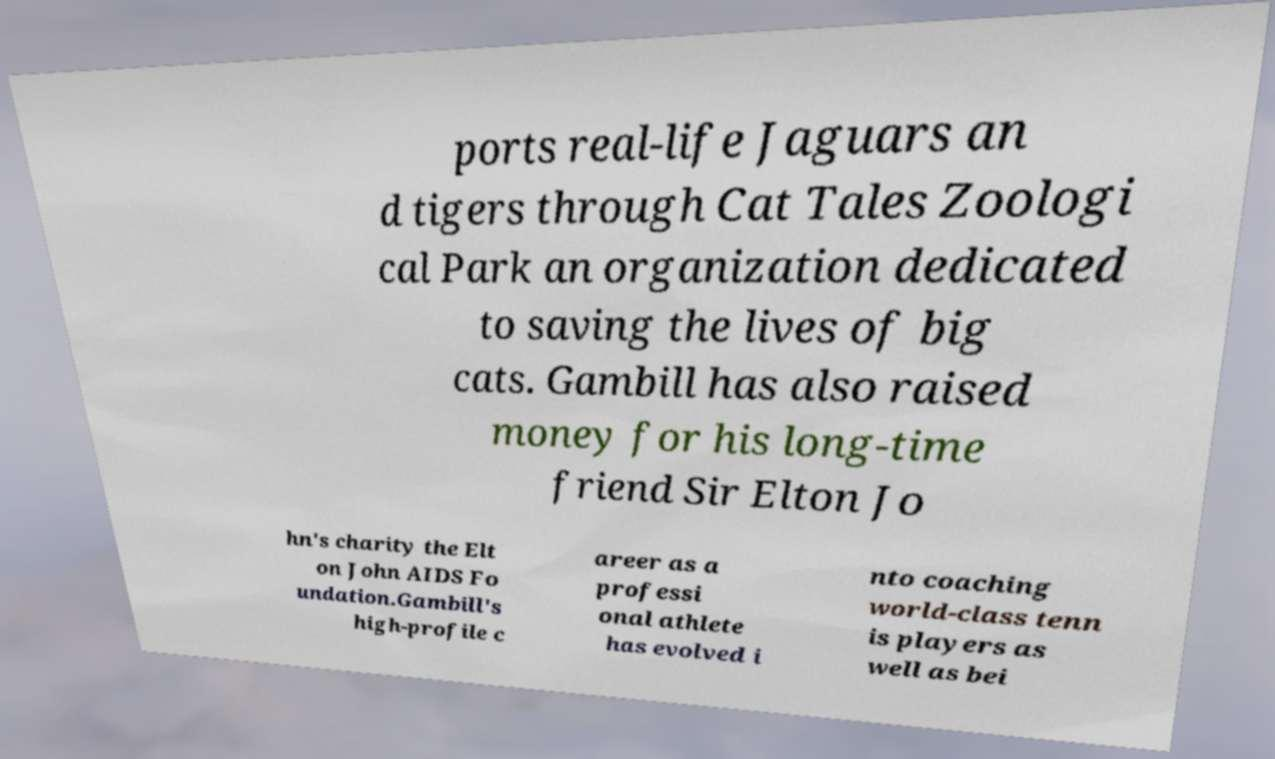What messages or text are displayed in this image? I need them in a readable, typed format. ports real-life Jaguars an d tigers through Cat Tales Zoologi cal Park an organization dedicated to saving the lives of big cats. Gambill has also raised money for his long-time friend Sir Elton Jo hn's charity the Elt on John AIDS Fo undation.Gambill's high-profile c areer as a professi onal athlete has evolved i nto coaching world-class tenn is players as well as bei 